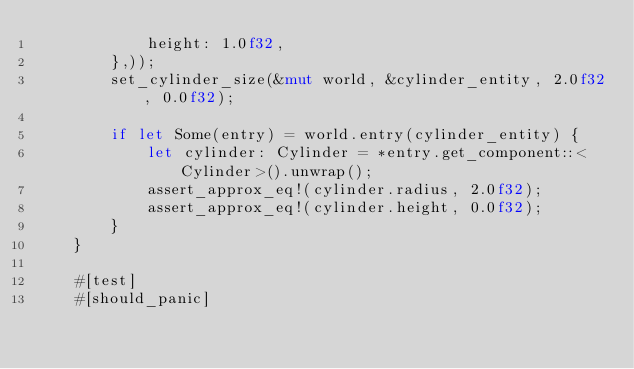Convert code to text. <code><loc_0><loc_0><loc_500><loc_500><_Rust_>            height: 1.0f32,
        },));
        set_cylinder_size(&mut world, &cylinder_entity, 2.0f32, 0.0f32);

        if let Some(entry) = world.entry(cylinder_entity) {
            let cylinder: Cylinder = *entry.get_component::<Cylinder>().unwrap();
            assert_approx_eq!(cylinder.radius, 2.0f32);
            assert_approx_eq!(cylinder.height, 0.0f32);
        }
    }

    #[test]
    #[should_panic]</code> 